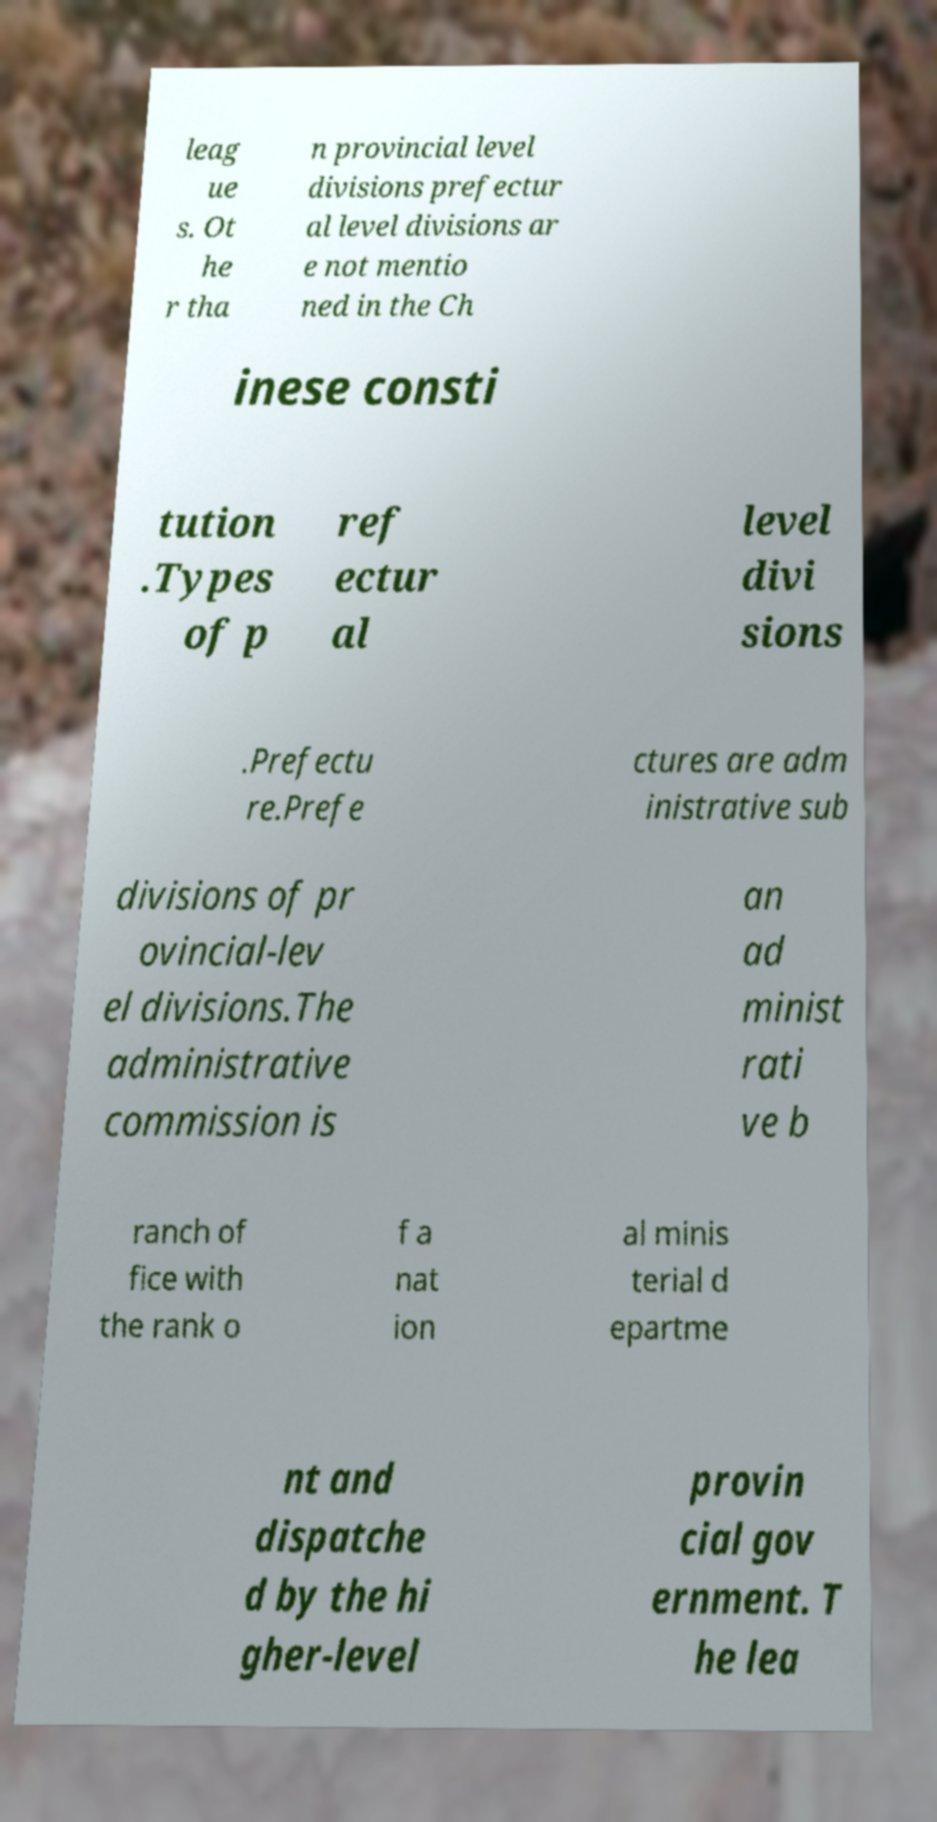For documentation purposes, I need the text within this image transcribed. Could you provide that? leag ue s. Ot he r tha n provincial level divisions prefectur al level divisions ar e not mentio ned in the Ch inese consti tution .Types of p ref ectur al level divi sions .Prefectu re.Prefe ctures are adm inistrative sub divisions of pr ovincial-lev el divisions.The administrative commission is an ad minist rati ve b ranch of fice with the rank o f a nat ion al minis terial d epartme nt and dispatche d by the hi gher-level provin cial gov ernment. T he lea 